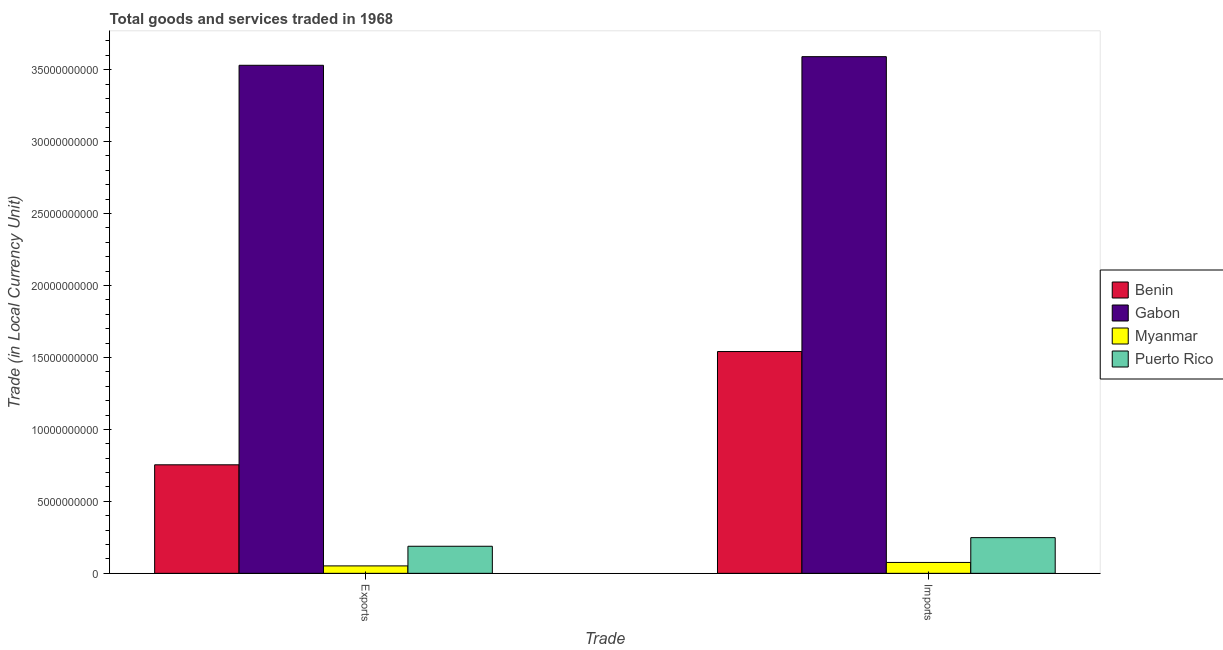How many groups of bars are there?
Your answer should be very brief. 2. How many bars are there on the 1st tick from the left?
Make the answer very short. 4. How many bars are there on the 2nd tick from the right?
Provide a short and direct response. 4. What is the label of the 2nd group of bars from the left?
Ensure brevity in your answer.  Imports. What is the imports of goods and services in Gabon?
Make the answer very short. 3.59e+1. Across all countries, what is the maximum export of goods and services?
Offer a very short reply. 3.53e+1. Across all countries, what is the minimum export of goods and services?
Keep it short and to the point. 5.16e+08. In which country was the imports of goods and services maximum?
Ensure brevity in your answer.  Gabon. In which country was the imports of goods and services minimum?
Provide a succinct answer. Myanmar. What is the total imports of goods and services in the graph?
Give a very brief answer. 5.45e+1. What is the difference between the export of goods and services in Myanmar and that in Gabon?
Provide a succinct answer. -3.48e+1. What is the difference between the imports of goods and services in Gabon and the export of goods and services in Puerto Rico?
Keep it short and to the point. 3.40e+1. What is the average export of goods and services per country?
Keep it short and to the point. 1.13e+1. What is the difference between the export of goods and services and imports of goods and services in Gabon?
Your answer should be compact. -6.00e+08. What is the ratio of the imports of goods and services in Puerto Rico to that in Benin?
Your answer should be very brief. 0.16. Is the imports of goods and services in Myanmar less than that in Benin?
Your response must be concise. Yes. What does the 4th bar from the left in Exports represents?
Ensure brevity in your answer.  Puerto Rico. What does the 3rd bar from the right in Exports represents?
Keep it short and to the point. Gabon. How many bars are there?
Keep it short and to the point. 8. Are all the bars in the graph horizontal?
Offer a terse response. No. How many countries are there in the graph?
Offer a terse response. 4. What is the difference between two consecutive major ticks on the Y-axis?
Your answer should be compact. 5.00e+09. Does the graph contain grids?
Your answer should be very brief. No. Where does the legend appear in the graph?
Ensure brevity in your answer.  Center right. How many legend labels are there?
Provide a succinct answer. 4. What is the title of the graph?
Your answer should be very brief. Total goods and services traded in 1968. Does "Fiji" appear as one of the legend labels in the graph?
Provide a short and direct response. No. What is the label or title of the X-axis?
Provide a short and direct response. Trade. What is the label or title of the Y-axis?
Provide a succinct answer. Trade (in Local Currency Unit). What is the Trade (in Local Currency Unit) of Benin in Exports?
Provide a short and direct response. 7.54e+09. What is the Trade (in Local Currency Unit) in Gabon in Exports?
Provide a succinct answer. 3.53e+1. What is the Trade (in Local Currency Unit) in Myanmar in Exports?
Make the answer very short. 5.16e+08. What is the Trade (in Local Currency Unit) of Puerto Rico in Exports?
Offer a very short reply. 1.88e+09. What is the Trade (in Local Currency Unit) in Benin in Imports?
Give a very brief answer. 1.54e+1. What is the Trade (in Local Currency Unit) of Gabon in Imports?
Provide a short and direct response. 3.59e+1. What is the Trade (in Local Currency Unit) of Myanmar in Imports?
Your response must be concise. 7.57e+08. What is the Trade (in Local Currency Unit) of Puerto Rico in Imports?
Provide a succinct answer. 2.48e+09. Across all Trade, what is the maximum Trade (in Local Currency Unit) in Benin?
Your answer should be very brief. 1.54e+1. Across all Trade, what is the maximum Trade (in Local Currency Unit) of Gabon?
Your response must be concise. 3.59e+1. Across all Trade, what is the maximum Trade (in Local Currency Unit) of Myanmar?
Offer a terse response. 7.57e+08. Across all Trade, what is the maximum Trade (in Local Currency Unit) of Puerto Rico?
Offer a very short reply. 2.48e+09. Across all Trade, what is the minimum Trade (in Local Currency Unit) of Benin?
Offer a terse response. 7.54e+09. Across all Trade, what is the minimum Trade (in Local Currency Unit) of Gabon?
Offer a very short reply. 3.53e+1. Across all Trade, what is the minimum Trade (in Local Currency Unit) in Myanmar?
Make the answer very short. 5.16e+08. Across all Trade, what is the minimum Trade (in Local Currency Unit) in Puerto Rico?
Offer a terse response. 1.88e+09. What is the total Trade (in Local Currency Unit) of Benin in the graph?
Keep it short and to the point. 2.30e+1. What is the total Trade (in Local Currency Unit) in Gabon in the graph?
Give a very brief answer. 7.12e+1. What is the total Trade (in Local Currency Unit) of Myanmar in the graph?
Give a very brief answer. 1.27e+09. What is the total Trade (in Local Currency Unit) of Puerto Rico in the graph?
Make the answer very short. 4.36e+09. What is the difference between the Trade (in Local Currency Unit) in Benin in Exports and that in Imports?
Your answer should be compact. -7.87e+09. What is the difference between the Trade (in Local Currency Unit) of Gabon in Exports and that in Imports?
Your answer should be very brief. -6.00e+08. What is the difference between the Trade (in Local Currency Unit) of Myanmar in Exports and that in Imports?
Provide a succinct answer. -2.41e+08. What is the difference between the Trade (in Local Currency Unit) of Puerto Rico in Exports and that in Imports?
Your answer should be very brief. -6.00e+08. What is the difference between the Trade (in Local Currency Unit) of Benin in Exports and the Trade (in Local Currency Unit) of Gabon in Imports?
Make the answer very short. -2.84e+1. What is the difference between the Trade (in Local Currency Unit) of Benin in Exports and the Trade (in Local Currency Unit) of Myanmar in Imports?
Provide a succinct answer. 6.78e+09. What is the difference between the Trade (in Local Currency Unit) in Benin in Exports and the Trade (in Local Currency Unit) in Puerto Rico in Imports?
Provide a succinct answer. 5.06e+09. What is the difference between the Trade (in Local Currency Unit) in Gabon in Exports and the Trade (in Local Currency Unit) in Myanmar in Imports?
Your response must be concise. 3.45e+1. What is the difference between the Trade (in Local Currency Unit) of Gabon in Exports and the Trade (in Local Currency Unit) of Puerto Rico in Imports?
Your answer should be very brief. 3.28e+1. What is the difference between the Trade (in Local Currency Unit) in Myanmar in Exports and the Trade (in Local Currency Unit) in Puerto Rico in Imports?
Offer a very short reply. -1.96e+09. What is the average Trade (in Local Currency Unit) of Benin per Trade?
Give a very brief answer. 1.15e+1. What is the average Trade (in Local Currency Unit) in Gabon per Trade?
Your answer should be compact. 3.56e+1. What is the average Trade (in Local Currency Unit) in Myanmar per Trade?
Offer a terse response. 6.36e+08. What is the average Trade (in Local Currency Unit) of Puerto Rico per Trade?
Ensure brevity in your answer.  2.18e+09. What is the difference between the Trade (in Local Currency Unit) in Benin and Trade (in Local Currency Unit) in Gabon in Exports?
Your response must be concise. -2.78e+1. What is the difference between the Trade (in Local Currency Unit) in Benin and Trade (in Local Currency Unit) in Myanmar in Exports?
Give a very brief answer. 7.03e+09. What is the difference between the Trade (in Local Currency Unit) of Benin and Trade (in Local Currency Unit) of Puerto Rico in Exports?
Give a very brief answer. 5.66e+09. What is the difference between the Trade (in Local Currency Unit) of Gabon and Trade (in Local Currency Unit) of Myanmar in Exports?
Your answer should be very brief. 3.48e+1. What is the difference between the Trade (in Local Currency Unit) in Gabon and Trade (in Local Currency Unit) in Puerto Rico in Exports?
Keep it short and to the point. 3.34e+1. What is the difference between the Trade (in Local Currency Unit) in Myanmar and Trade (in Local Currency Unit) in Puerto Rico in Exports?
Keep it short and to the point. -1.36e+09. What is the difference between the Trade (in Local Currency Unit) of Benin and Trade (in Local Currency Unit) of Gabon in Imports?
Your response must be concise. -2.05e+1. What is the difference between the Trade (in Local Currency Unit) of Benin and Trade (in Local Currency Unit) of Myanmar in Imports?
Ensure brevity in your answer.  1.47e+1. What is the difference between the Trade (in Local Currency Unit) of Benin and Trade (in Local Currency Unit) of Puerto Rico in Imports?
Your response must be concise. 1.29e+1. What is the difference between the Trade (in Local Currency Unit) in Gabon and Trade (in Local Currency Unit) in Myanmar in Imports?
Keep it short and to the point. 3.51e+1. What is the difference between the Trade (in Local Currency Unit) of Gabon and Trade (in Local Currency Unit) of Puerto Rico in Imports?
Provide a short and direct response. 3.34e+1. What is the difference between the Trade (in Local Currency Unit) of Myanmar and Trade (in Local Currency Unit) of Puerto Rico in Imports?
Ensure brevity in your answer.  -1.72e+09. What is the ratio of the Trade (in Local Currency Unit) of Benin in Exports to that in Imports?
Offer a terse response. 0.49. What is the ratio of the Trade (in Local Currency Unit) of Gabon in Exports to that in Imports?
Provide a short and direct response. 0.98. What is the ratio of the Trade (in Local Currency Unit) in Myanmar in Exports to that in Imports?
Your response must be concise. 0.68. What is the ratio of the Trade (in Local Currency Unit) in Puerto Rico in Exports to that in Imports?
Offer a terse response. 0.76. What is the difference between the highest and the second highest Trade (in Local Currency Unit) in Benin?
Offer a very short reply. 7.87e+09. What is the difference between the highest and the second highest Trade (in Local Currency Unit) of Gabon?
Keep it short and to the point. 6.00e+08. What is the difference between the highest and the second highest Trade (in Local Currency Unit) of Myanmar?
Your response must be concise. 2.41e+08. What is the difference between the highest and the second highest Trade (in Local Currency Unit) in Puerto Rico?
Keep it short and to the point. 6.00e+08. What is the difference between the highest and the lowest Trade (in Local Currency Unit) of Benin?
Your response must be concise. 7.87e+09. What is the difference between the highest and the lowest Trade (in Local Currency Unit) in Gabon?
Your answer should be compact. 6.00e+08. What is the difference between the highest and the lowest Trade (in Local Currency Unit) of Myanmar?
Your answer should be compact. 2.41e+08. What is the difference between the highest and the lowest Trade (in Local Currency Unit) of Puerto Rico?
Your answer should be very brief. 6.00e+08. 